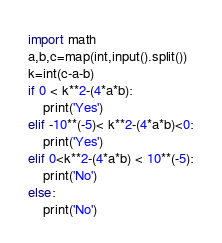<code> <loc_0><loc_0><loc_500><loc_500><_Python_>import math
a,b,c=map(int,input().split())
k=int(c-a-b)
if 0 < k**2-(4*a*b):
    print('Yes')
elif -10**(-5)< k**2-(4*a*b)<0:
    print('Yes')
elif 0<k**2-(4*a*b) < 10**(-5):
    print('No')
else:
    print('No')</code> 